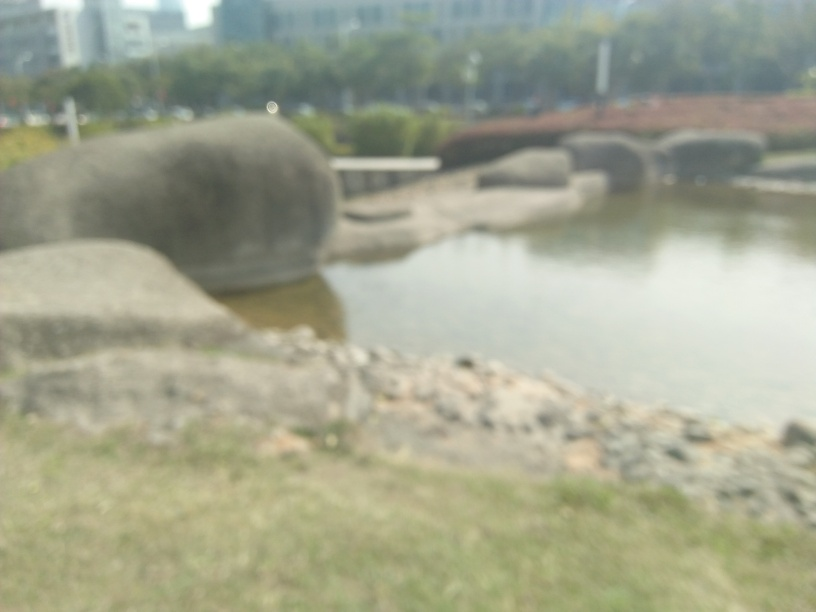What might be the reason for the poor quality of the image? The poor quality of the image could be due to several factors, such as camera movement during the shot, an out-of-focus lens, or a deliberate artistic choice. It could also result from a low-resolution camera or improper camera settings not suited to the environmental conditions. 